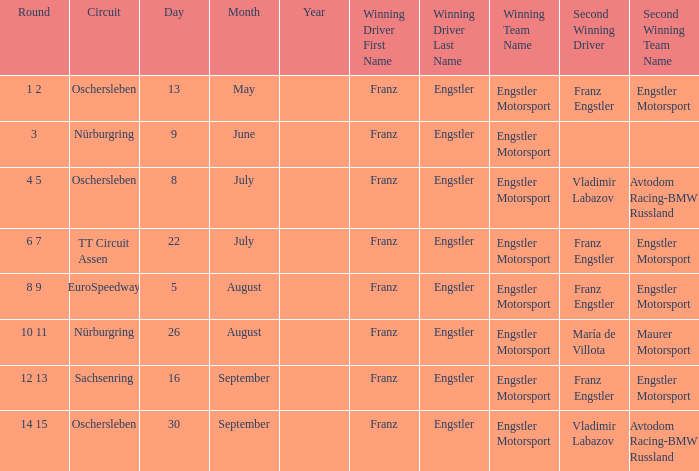With a Date of 22 July, what is the Winning team? Engstler Motorsport Engstler Motorsport. 